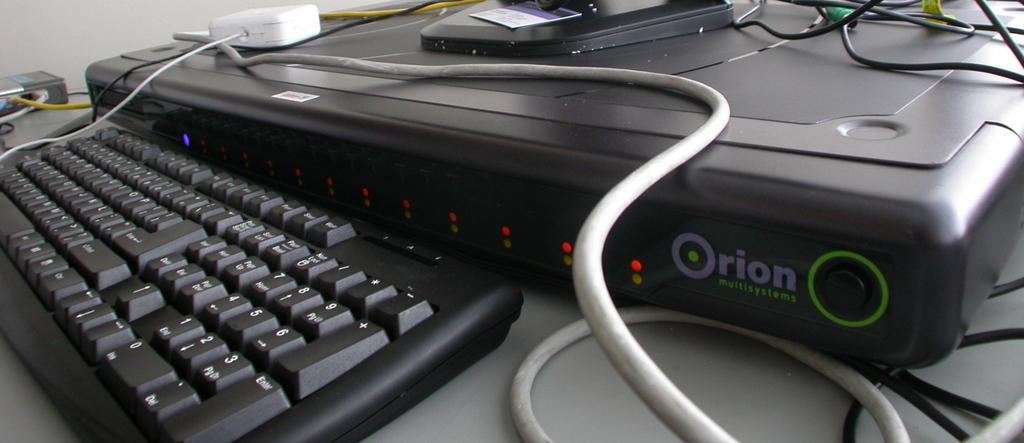<image>
Render a clear and concise summary of the photo. a digital device in front of a keyboard that says 'orion' on it 